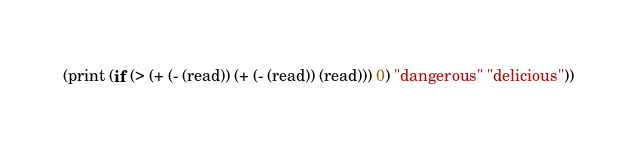Convert code to text. <code><loc_0><loc_0><loc_500><loc_500><_Scheme_>(print (if (> (+ (- (read)) (+ (- (read)) (read))) 0) "dangerous" "delicious"))</code> 